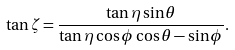Convert formula to latex. <formula><loc_0><loc_0><loc_500><loc_500>\tan \zeta = \frac { \tan \eta \sin \theta } { \tan \eta \cos \phi \cos \theta - \sin \phi } .</formula> 